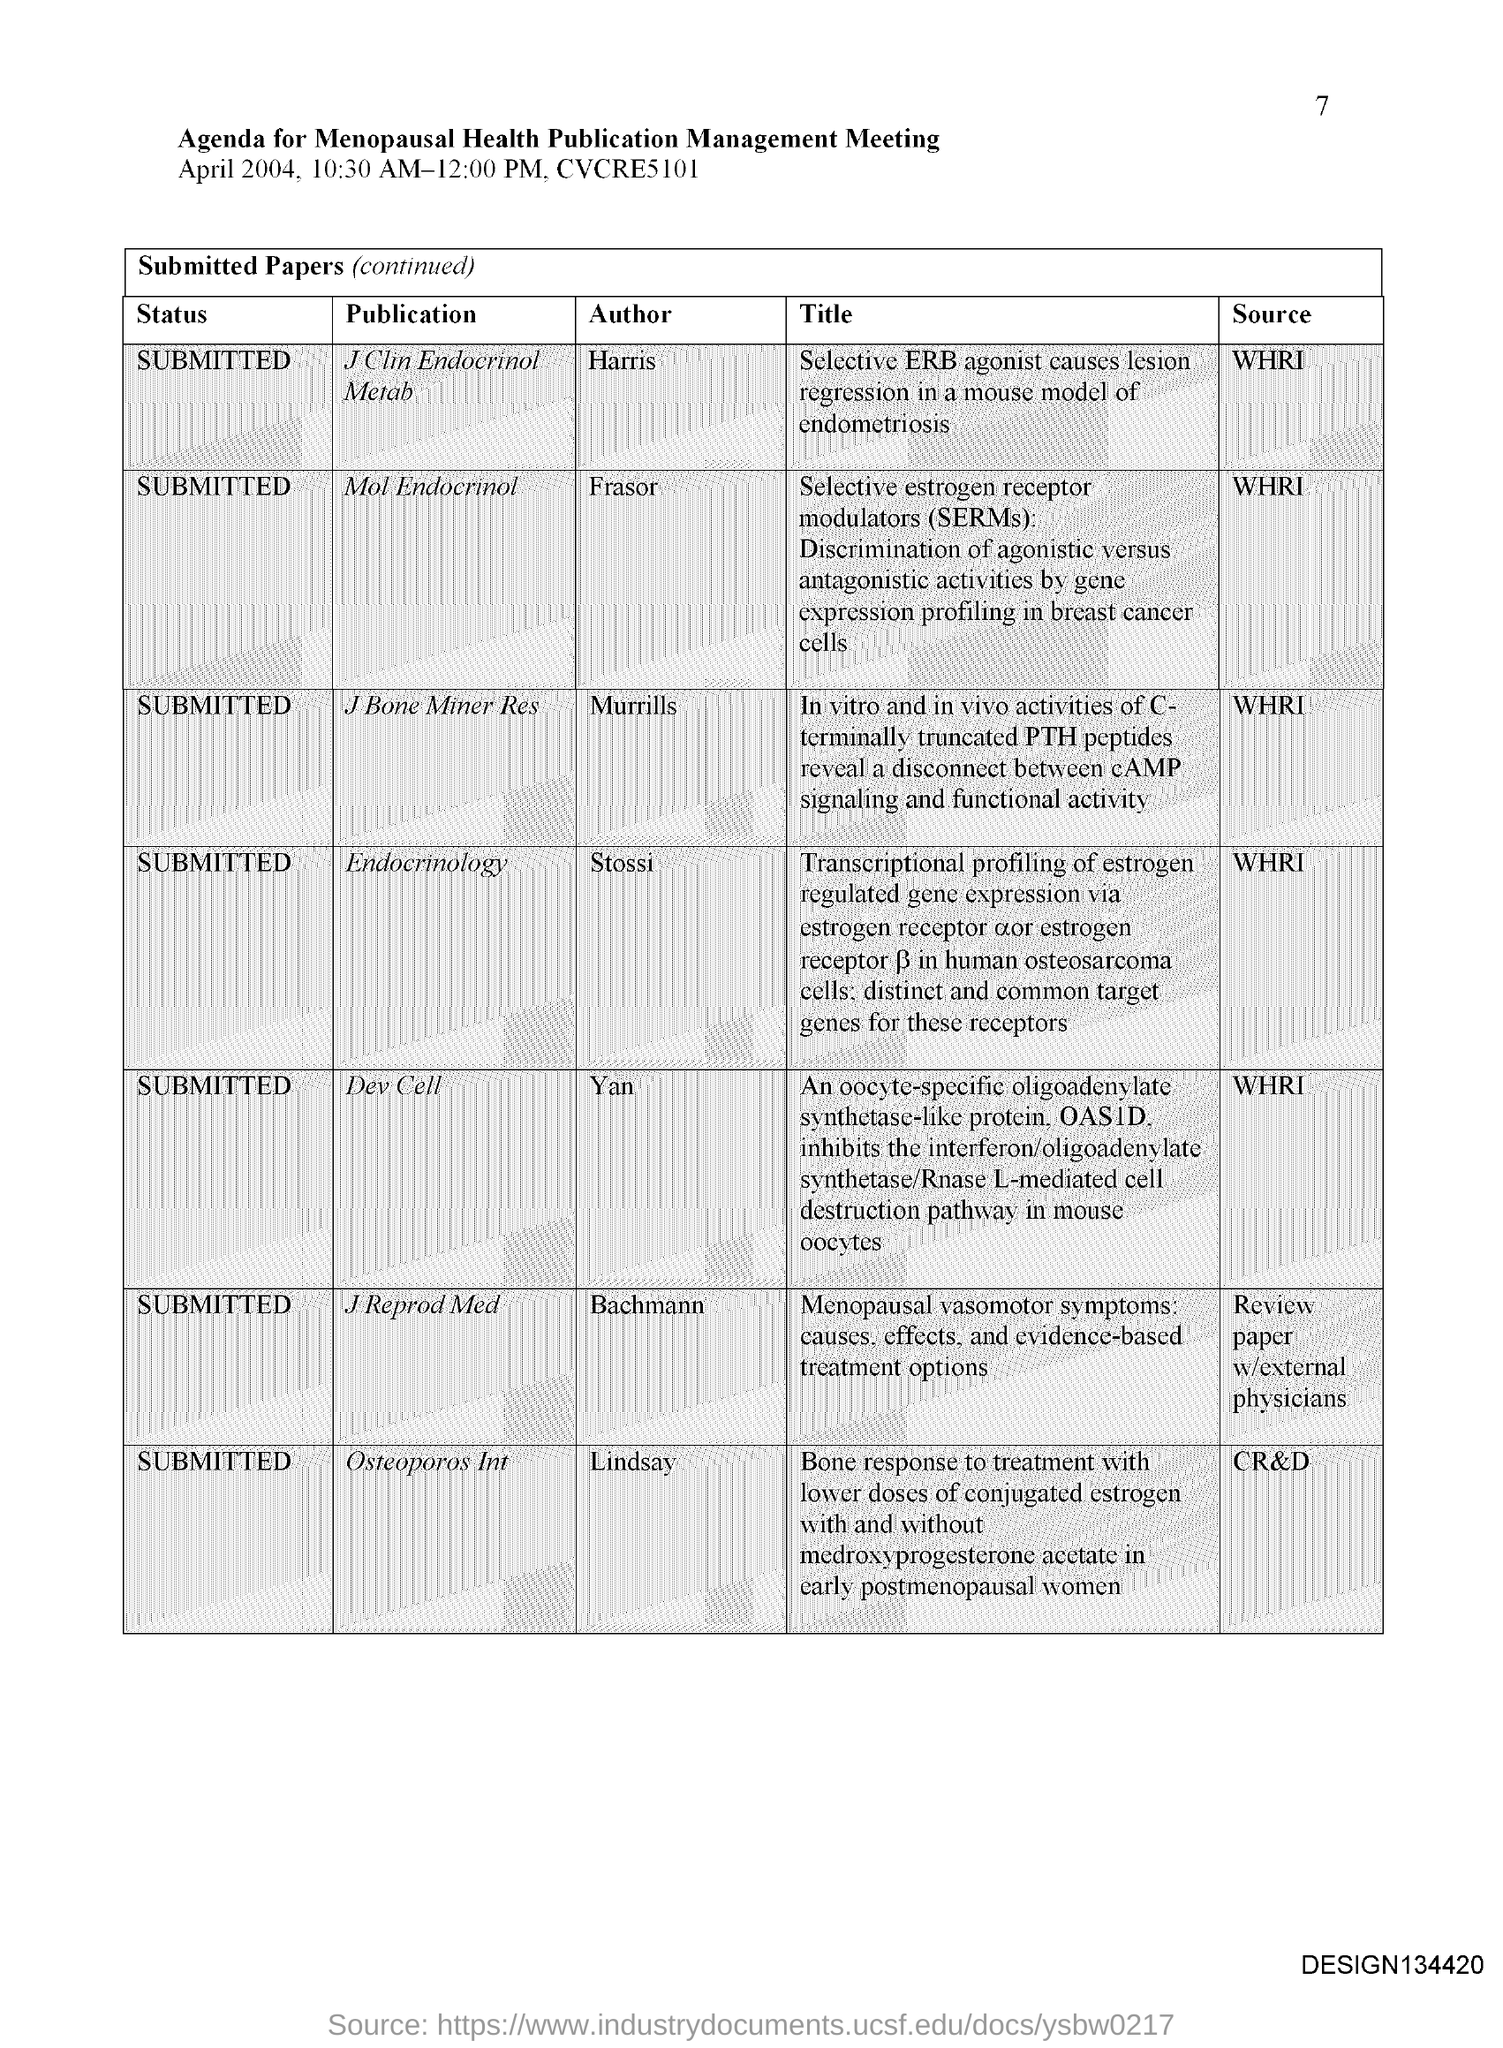Who is the author of the publication Mol Endocrinol?
Give a very brief answer. Frasor. Who is the author of the publication Endocrinology?
Your answer should be very brief. Stossi. Who is the author of the publication Dev Cell?
Your response must be concise. Yan. Who is the author of the publication Osteoporos Int?
Offer a terse response. Lindsay. 